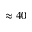Convert formula to latex. <formula><loc_0><loc_0><loc_500><loc_500>\approx 4 0</formula> 